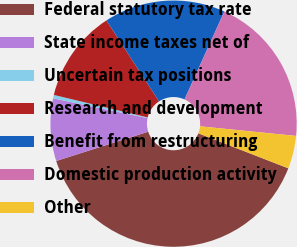Convert chart to OTSL. <chart><loc_0><loc_0><loc_500><loc_500><pie_chart><fcel>Federal statutory tax rate<fcel>State income taxes net of<fcel>Uncertain tax positions<fcel>Research and development<fcel>Benefit from restructuring<fcel>Domestic production activity<fcel>Other<nl><fcel>39.19%<fcel>8.2%<fcel>0.45%<fcel>12.07%<fcel>15.95%<fcel>19.82%<fcel>4.32%<nl></chart> 